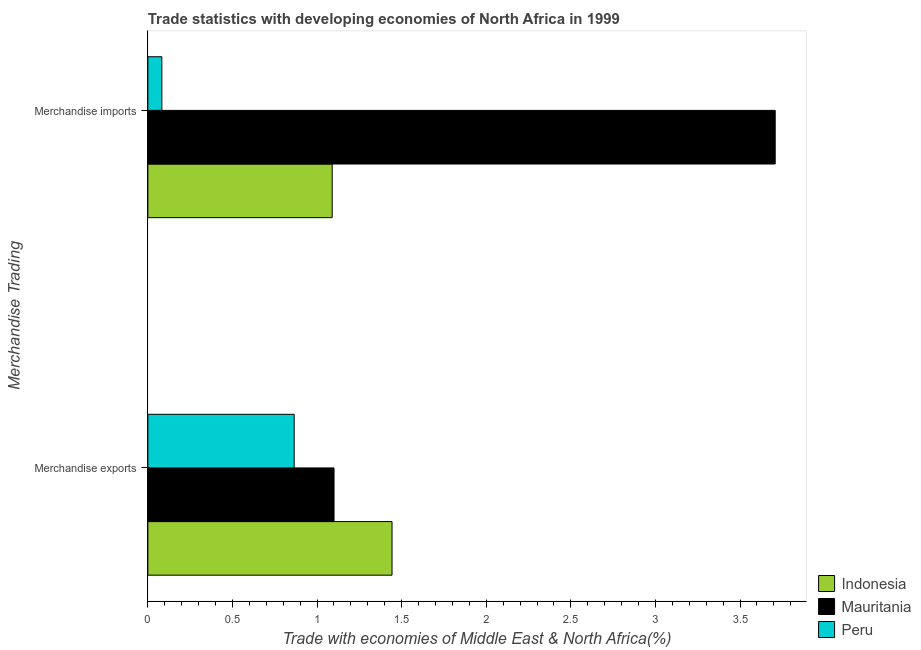How many different coloured bars are there?
Ensure brevity in your answer.  3. How many groups of bars are there?
Offer a very short reply. 2. Are the number of bars on each tick of the Y-axis equal?
Offer a terse response. Yes. What is the merchandise imports in Peru?
Provide a short and direct response. 0.08. Across all countries, what is the maximum merchandise exports?
Offer a terse response. 1.44. Across all countries, what is the minimum merchandise exports?
Offer a very short reply. 0.86. What is the total merchandise imports in the graph?
Ensure brevity in your answer.  4.88. What is the difference between the merchandise exports in Mauritania and that in Indonesia?
Give a very brief answer. -0.34. What is the difference between the merchandise imports in Indonesia and the merchandise exports in Peru?
Your response must be concise. 0.22. What is the average merchandise imports per country?
Offer a very short reply. 1.63. What is the difference between the merchandise exports and merchandise imports in Mauritania?
Ensure brevity in your answer.  -2.61. What is the ratio of the merchandise imports in Indonesia to that in Peru?
Your response must be concise. 13.18. What does the 2nd bar from the top in Merchandise exports represents?
Provide a succinct answer. Mauritania. What does the 2nd bar from the bottom in Merchandise imports represents?
Offer a very short reply. Mauritania. Are all the bars in the graph horizontal?
Offer a very short reply. Yes. How many countries are there in the graph?
Provide a short and direct response. 3. Does the graph contain grids?
Provide a succinct answer. No. How are the legend labels stacked?
Offer a terse response. Vertical. What is the title of the graph?
Make the answer very short. Trade statistics with developing economies of North Africa in 1999. What is the label or title of the X-axis?
Provide a short and direct response. Trade with economies of Middle East & North Africa(%). What is the label or title of the Y-axis?
Make the answer very short. Merchandise Trading. What is the Trade with economies of Middle East & North Africa(%) in Indonesia in Merchandise exports?
Ensure brevity in your answer.  1.44. What is the Trade with economies of Middle East & North Africa(%) of Mauritania in Merchandise exports?
Your answer should be compact. 1.1. What is the Trade with economies of Middle East & North Africa(%) of Peru in Merchandise exports?
Provide a short and direct response. 0.86. What is the Trade with economies of Middle East & North Africa(%) of Indonesia in Merchandise imports?
Your answer should be compact. 1.09. What is the Trade with economies of Middle East & North Africa(%) in Mauritania in Merchandise imports?
Give a very brief answer. 3.71. What is the Trade with economies of Middle East & North Africa(%) in Peru in Merchandise imports?
Offer a very short reply. 0.08. Across all Merchandise Trading, what is the maximum Trade with economies of Middle East & North Africa(%) of Indonesia?
Keep it short and to the point. 1.44. Across all Merchandise Trading, what is the maximum Trade with economies of Middle East & North Africa(%) of Mauritania?
Your answer should be very brief. 3.71. Across all Merchandise Trading, what is the maximum Trade with economies of Middle East & North Africa(%) of Peru?
Ensure brevity in your answer.  0.86. Across all Merchandise Trading, what is the minimum Trade with economies of Middle East & North Africa(%) of Indonesia?
Offer a very short reply. 1.09. Across all Merchandise Trading, what is the minimum Trade with economies of Middle East & North Africa(%) in Mauritania?
Your response must be concise. 1.1. Across all Merchandise Trading, what is the minimum Trade with economies of Middle East & North Africa(%) of Peru?
Provide a succinct answer. 0.08. What is the total Trade with economies of Middle East & North Africa(%) of Indonesia in the graph?
Provide a short and direct response. 2.53. What is the total Trade with economies of Middle East & North Africa(%) of Mauritania in the graph?
Give a very brief answer. 4.81. What is the total Trade with economies of Middle East & North Africa(%) of Peru in the graph?
Keep it short and to the point. 0.95. What is the difference between the Trade with economies of Middle East & North Africa(%) of Indonesia in Merchandise exports and that in Merchandise imports?
Make the answer very short. 0.35. What is the difference between the Trade with economies of Middle East & North Africa(%) of Mauritania in Merchandise exports and that in Merchandise imports?
Your answer should be compact. -2.61. What is the difference between the Trade with economies of Middle East & North Africa(%) of Peru in Merchandise exports and that in Merchandise imports?
Provide a short and direct response. 0.78. What is the difference between the Trade with economies of Middle East & North Africa(%) in Indonesia in Merchandise exports and the Trade with economies of Middle East & North Africa(%) in Mauritania in Merchandise imports?
Provide a succinct answer. -2.26. What is the difference between the Trade with economies of Middle East & North Africa(%) of Indonesia in Merchandise exports and the Trade with economies of Middle East & North Africa(%) of Peru in Merchandise imports?
Offer a terse response. 1.36. What is the difference between the Trade with economies of Middle East & North Africa(%) in Mauritania in Merchandise exports and the Trade with economies of Middle East & North Africa(%) in Peru in Merchandise imports?
Offer a terse response. 1.02. What is the average Trade with economies of Middle East & North Africa(%) of Indonesia per Merchandise Trading?
Offer a terse response. 1.27. What is the average Trade with economies of Middle East & North Africa(%) in Mauritania per Merchandise Trading?
Your answer should be very brief. 2.4. What is the average Trade with economies of Middle East & North Africa(%) in Peru per Merchandise Trading?
Your answer should be compact. 0.47. What is the difference between the Trade with economies of Middle East & North Africa(%) in Indonesia and Trade with economies of Middle East & North Africa(%) in Mauritania in Merchandise exports?
Provide a succinct answer. 0.34. What is the difference between the Trade with economies of Middle East & North Africa(%) in Indonesia and Trade with economies of Middle East & North Africa(%) in Peru in Merchandise exports?
Offer a terse response. 0.58. What is the difference between the Trade with economies of Middle East & North Africa(%) of Mauritania and Trade with economies of Middle East & North Africa(%) of Peru in Merchandise exports?
Offer a very short reply. 0.24. What is the difference between the Trade with economies of Middle East & North Africa(%) in Indonesia and Trade with economies of Middle East & North Africa(%) in Mauritania in Merchandise imports?
Offer a terse response. -2.62. What is the difference between the Trade with economies of Middle East & North Africa(%) in Indonesia and Trade with economies of Middle East & North Africa(%) in Peru in Merchandise imports?
Provide a short and direct response. 1.01. What is the difference between the Trade with economies of Middle East & North Africa(%) in Mauritania and Trade with economies of Middle East & North Africa(%) in Peru in Merchandise imports?
Your response must be concise. 3.63. What is the ratio of the Trade with economies of Middle East & North Africa(%) of Indonesia in Merchandise exports to that in Merchandise imports?
Offer a very short reply. 1.32. What is the ratio of the Trade with economies of Middle East & North Africa(%) of Mauritania in Merchandise exports to that in Merchandise imports?
Your response must be concise. 0.3. What is the ratio of the Trade with economies of Middle East & North Africa(%) of Peru in Merchandise exports to that in Merchandise imports?
Offer a very short reply. 10.46. What is the difference between the highest and the second highest Trade with economies of Middle East & North Africa(%) in Indonesia?
Provide a short and direct response. 0.35. What is the difference between the highest and the second highest Trade with economies of Middle East & North Africa(%) of Mauritania?
Give a very brief answer. 2.61. What is the difference between the highest and the second highest Trade with economies of Middle East & North Africa(%) of Peru?
Offer a terse response. 0.78. What is the difference between the highest and the lowest Trade with economies of Middle East & North Africa(%) of Indonesia?
Offer a terse response. 0.35. What is the difference between the highest and the lowest Trade with economies of Middle East & North Africa(%) of Mauritania?
Provide a short and direct response. 2.61. What is the difference between the highest and the lowest Trade with economies of Middle East & North Africa(%) in Peru?
Ensure brevity in your answer.  0.78. 